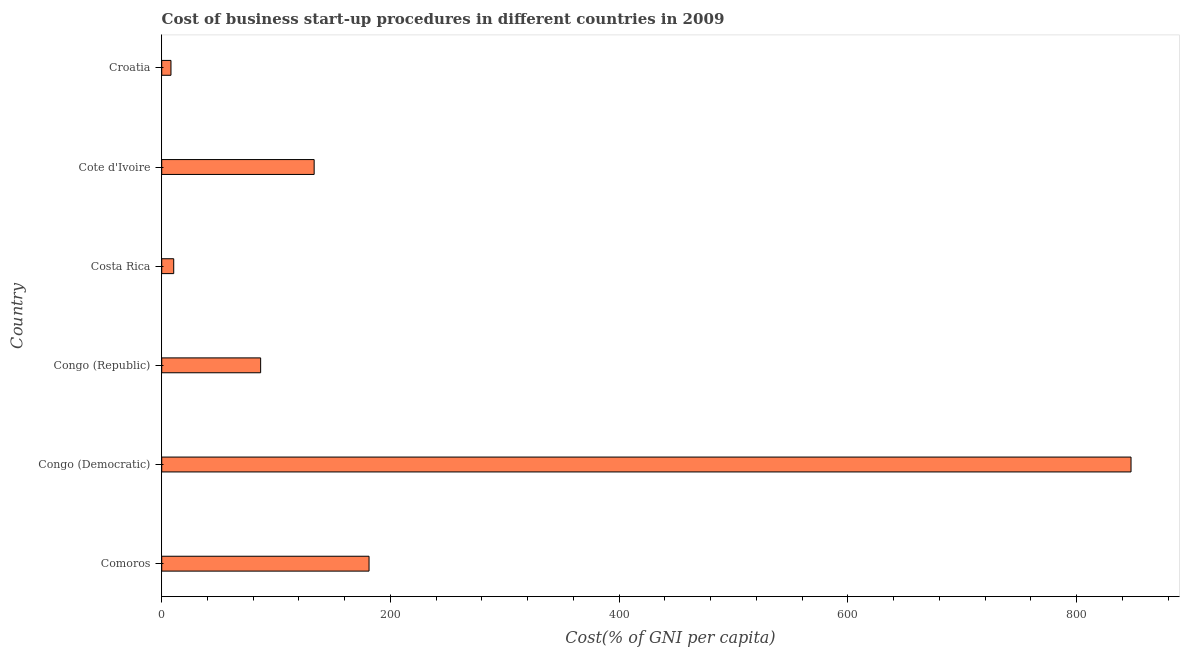Does the graph contain any zero values?
Your response must be concise. No. What is the title of the graph?
Provide a succinct answer. Cost of business start-up procedures in different countries in 2009. What is the label or title of the X-axis?
Your response must be concise. Cost(% of GNI per capita). What is the cost of business startup procedures in Congo (Republic)?
Give a very brief answer. 86.5. Across all countries, what is the maximum cost of business startup procedures?
Offer a very short reply. 847.6. Across all countries, what is the minimum cost of business startup procedures?
Offer a terse response. 8.1. In which country was the cost of business startup procedures maximum?
Your response must be concise. Congo (Democratic). In which country was the cost of business startup procedures minimum?
Make the answer very short. Croatia. What is the sum of the cost of business startup procedures?
Provide a short and direct response. 1267.3. What is the difference between the cost of business startup procedures in Comoros and Cote d'Ivoire?
Offer a very short reply. 48. What is the average cost of business startup procedures per country?
Give a very brief answer. 211.22. What is the median cost of business startup procedures?
Give a very brief answer. 109.9. What is the ratio of the cost of business startup procedures in Congo (Democratic) to that in Costa Rica?
Make the answer very short. 80.72. Is the difference between the cost of business startup procedures in Comoros and Congo (Republic) greater than the difference between any two countries?
Keep it short and to the point. No. What is the difference between the highest and the second highest cost of business startup procedures?
Keep it short and to the point. 666.3. What is the difference between the highest and the lowest cost of business startup procedures?
Offer a very short reply. 839.5. In how many countries, is the cost of business startup procedures greater than the average cost of business startup procedures taken over all countries?
Your answer should be very brief. 1. Are all the bars in the graph horizontal?
Keep it short and to the point. Yes. How many countries are there in the graph?
Offer a terse response. 6. What is the difference between two consecutive major ticks on the X-axis?
Your answer should be very brief. 200. Are the values on the major ticks of X-axis written in scientific E-notation?
Provide a short and direct response. No. What is the Cost(% of GNI per capita) in Comoros?
Offer a very short reply. 181.3. What is the Cost(% of GNI per capita) of Congo (Democratic)?
Provide a succinct answer. 847.6. What is the Cost(% of GNI per capita) in Congo (Republic)?
Your response must be concise. 86.5. What is the Cost(% of GNI per capita) in Cote d'Ivoire?
Keep it short and to the point. 133.3. What is the difference between the Cost(% of GNI per capita) in Comoros and Congo (Democratic)?
Offer a very short reply. -666.3. What is the difference between the Cost(% of GNI per capita) in Comoros and Congo (Republic)?
Make the answer very short. 94.8. What is the difference between the Cost(% of GNI per capita) in Comoros and Costa Rica?
Offer a very short reply. 170.8. What is the difference between the Cost(% of GNI per capita) in Comoros and Croatia?
Your answer should be compact. 173.2. What is the difference between the Cost(% of GNI per capita) in Congo (Democratic) and Congo (Republic)?
Your response must be concise. 761.1. What is the difference between the Cost(% of GNI per capita) in Congo (Democratic) and Costa Rica?
Your answer should be compact. 837.1. What is the difference between the Cost(% of GNI per capita) in Congo (Democratic) and Cote d'Ivoire?
Make the answer very short. 714.3. What is the difference between the Cost(% of GNI per capita) in Congo (Democratic) and Croatia?
Give a very brief answer. 839.5. What is the difference between the Cost(% of GNI per capita) in Congo (Republic) and Cote d'Ivoire?
Offer a very short reply. -46.8. What is the difference between the Cost(% of GNI per capita) in Congo (Republic) and Croatia?
Ensure brevity in your answer.  78.4. What is the difference between the Cost(% of GNI per capita) in Costa Rica and Cote d'Ivoire?
Your answer should be compact. -122.8. What is the difference between the Cost(% of GNI per capita) in Costa Rica and Croatia?
Your response must be concise. 2.4. What is the difference between the Cost(% of GNI per capita) in Cote d'Ivoire and Croatia?
Provide a short and direct response. 125.2. What is the ratio of the Cost(% of GNI per capita) in Comoros to that in Congo (Democratic)?
Offer a very short reply. 0.21. What is the ratio of the Cost(% of GNI per capita) in Comoros to that in Congo (Republic)?
Your answer should be very brief. 2.1. What is the ratio of the Cost(% of GNI per capita) in Comoros to that in Costa Rica?
Offer a very short reply. 17.27. What is the ratio of the Cost(% of GNI per capita) in Comoros to that in Cote d'Ivoire?
Give a very brief answer. 1.36. What is the ratio of the Cost(% of GNI per capita) in Comoros to that in Croatia?
Give a very brief answer. 22.38. What is the ratio of the Cost(% of GNI per capita) in Congo (Democratic) to that in Congo (Republic)?
Offer a terse response. 9.8. What is the ratio of the Cost(% of GNI per capita) in Congo (Democratic) to that in Costa Rica?
Your response must be concise. 80.72. What is the ratio of the Cost(% of GNI per capita) in Congo (Democratic) to that in Cote d'Ivoire?
Offer a very short reply. 6.36. What is the ratio of the Cost(% of GNI per capita) in Congo (Democratic) to that in Croatia?
Make the answer very short. 104.64. What is the ratio of the Cost(% of GNI per capita) in Congo (Republic) to that in Costa Rica?
Your answer should be compact. 8.24. What is the ratio of the Cost(% of GNI per capita) in Congo (Republic) to that in Cote d'Ivoire?
Your answer should be very brief. 0.65. What is the ratio of the Cost(% of GNI per capita) in Congo (Republic) to that in Croatia?
Offer a terse response. 10.68. What is the ratio of the Cost(% of GNI per capita) in Costa Rica to that in Cote d'Ivoire?
Your response must be concise. 0.08. What is the ratio of the Cost(% of GNI per capita) in Costa Rica to that in Croatia?
Make the answer very short. 1.3. What is the ratio of the Cost(% of GNI per capita) in Cote d'Ivoire to that in Croatia?
Provide a short and direct response. 16.46. 